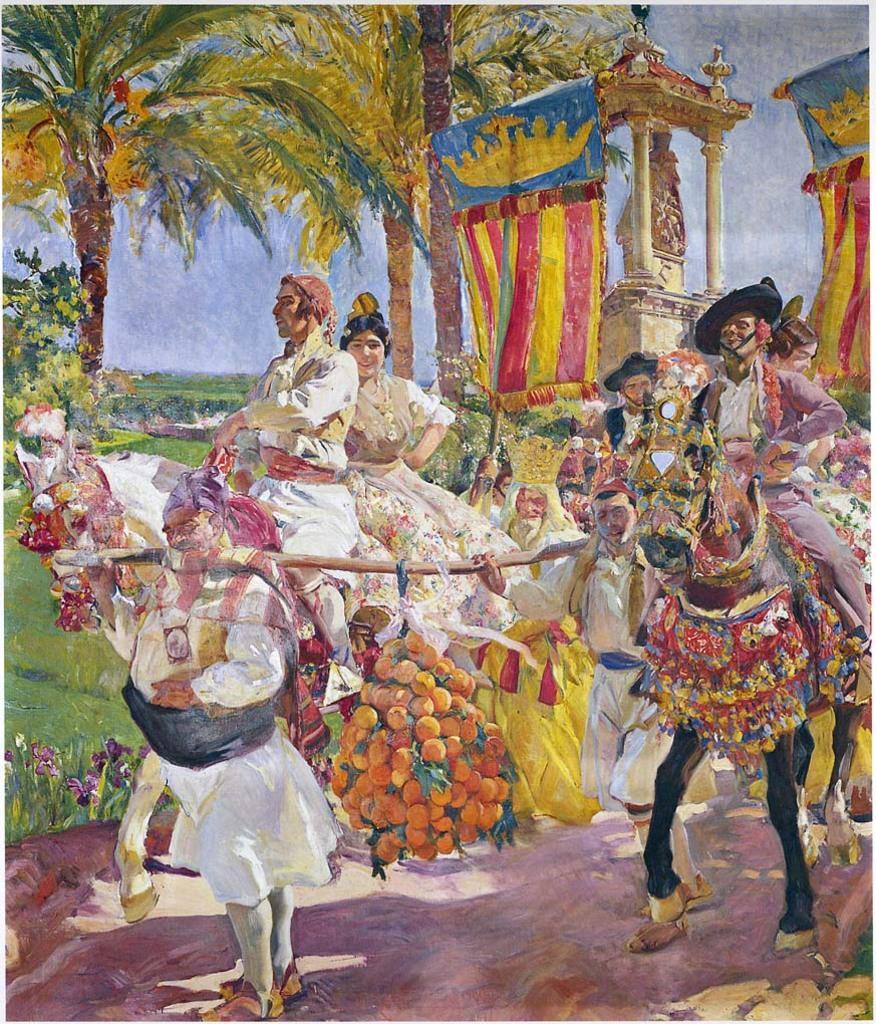Could you give a brief overview of what you see in this image? In this image I can see a painting, in the painting I can see there are few people visible on the horse, there are two people holding a stick on which there may be fruits hanging, behind the persons there are trees, the sky, flowering plant, carriage visible. 